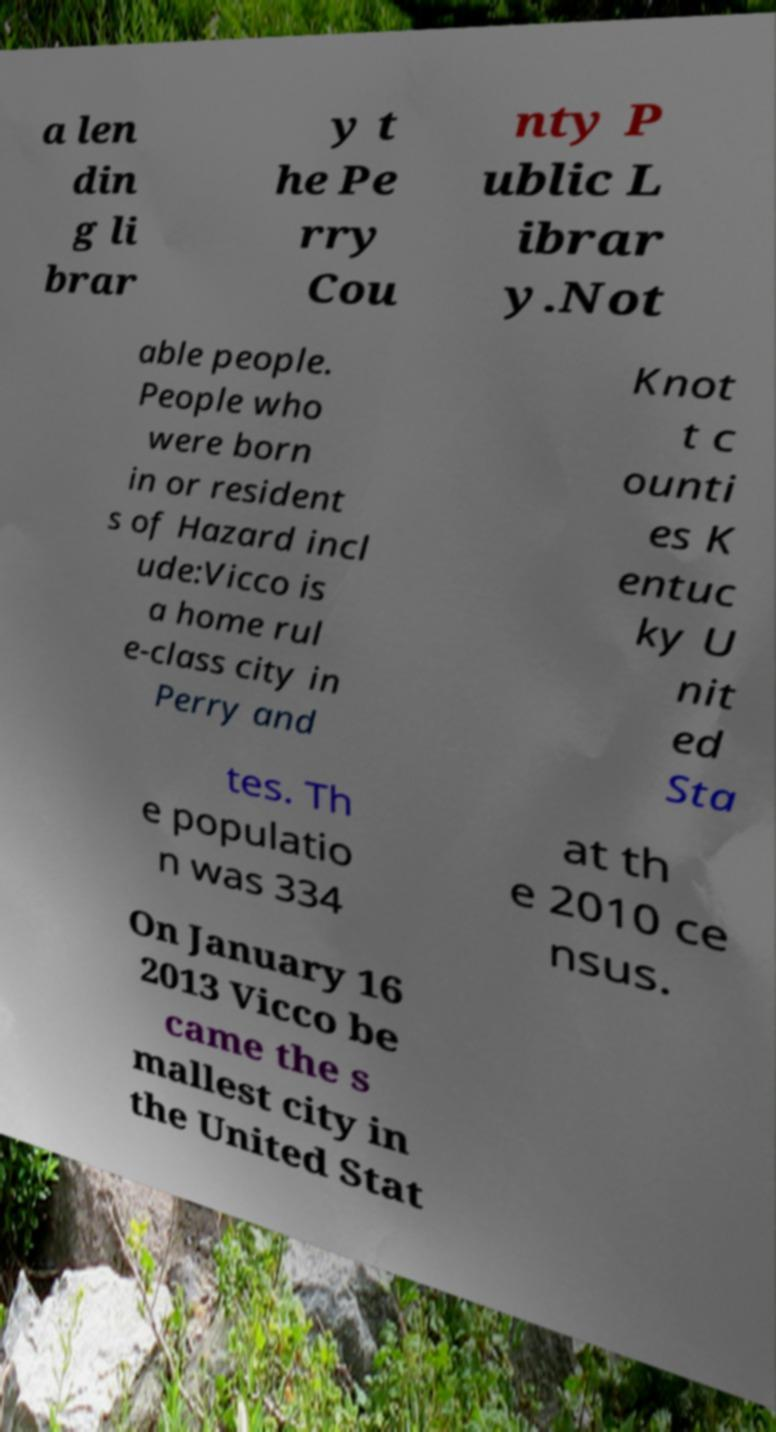There's text embedded in this image that I need extracted. Can you transcribe it verbatim? a len din g li brar y t he Pe rry Cou nty P ublic L ibrar y.Not able people. People who were born in or resident s of Hazard incl ude:Vicco is a home rul e-class city in Perry and Knot t c ounti es K entuc ky U nit ed Sta tes. Th e populatio n was 334 at th e 2010 ce nsus. On January 16 2013 Vicco be came the s mallest city in the United Stat 